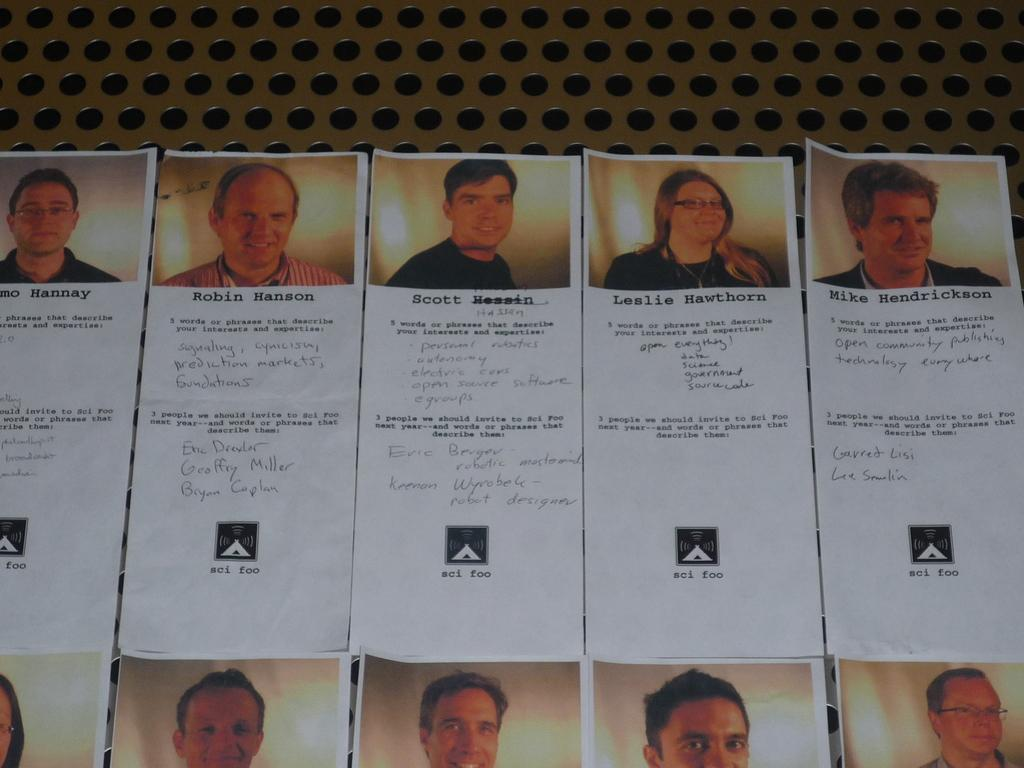What is located in the center of the image? There are posters in the center of the image. What can be seen on the posters? There are people smiling on the posters. What else is featured on the posters besides the images? There is writing on the posters. How many maids are present in the image? There are no maids present in the image; the posters feature smiling people, but their occupations are not specified. What type of feet can be seen on the posters? There are no feet visible on the posters; the focus is on the smiling people and the writing. 